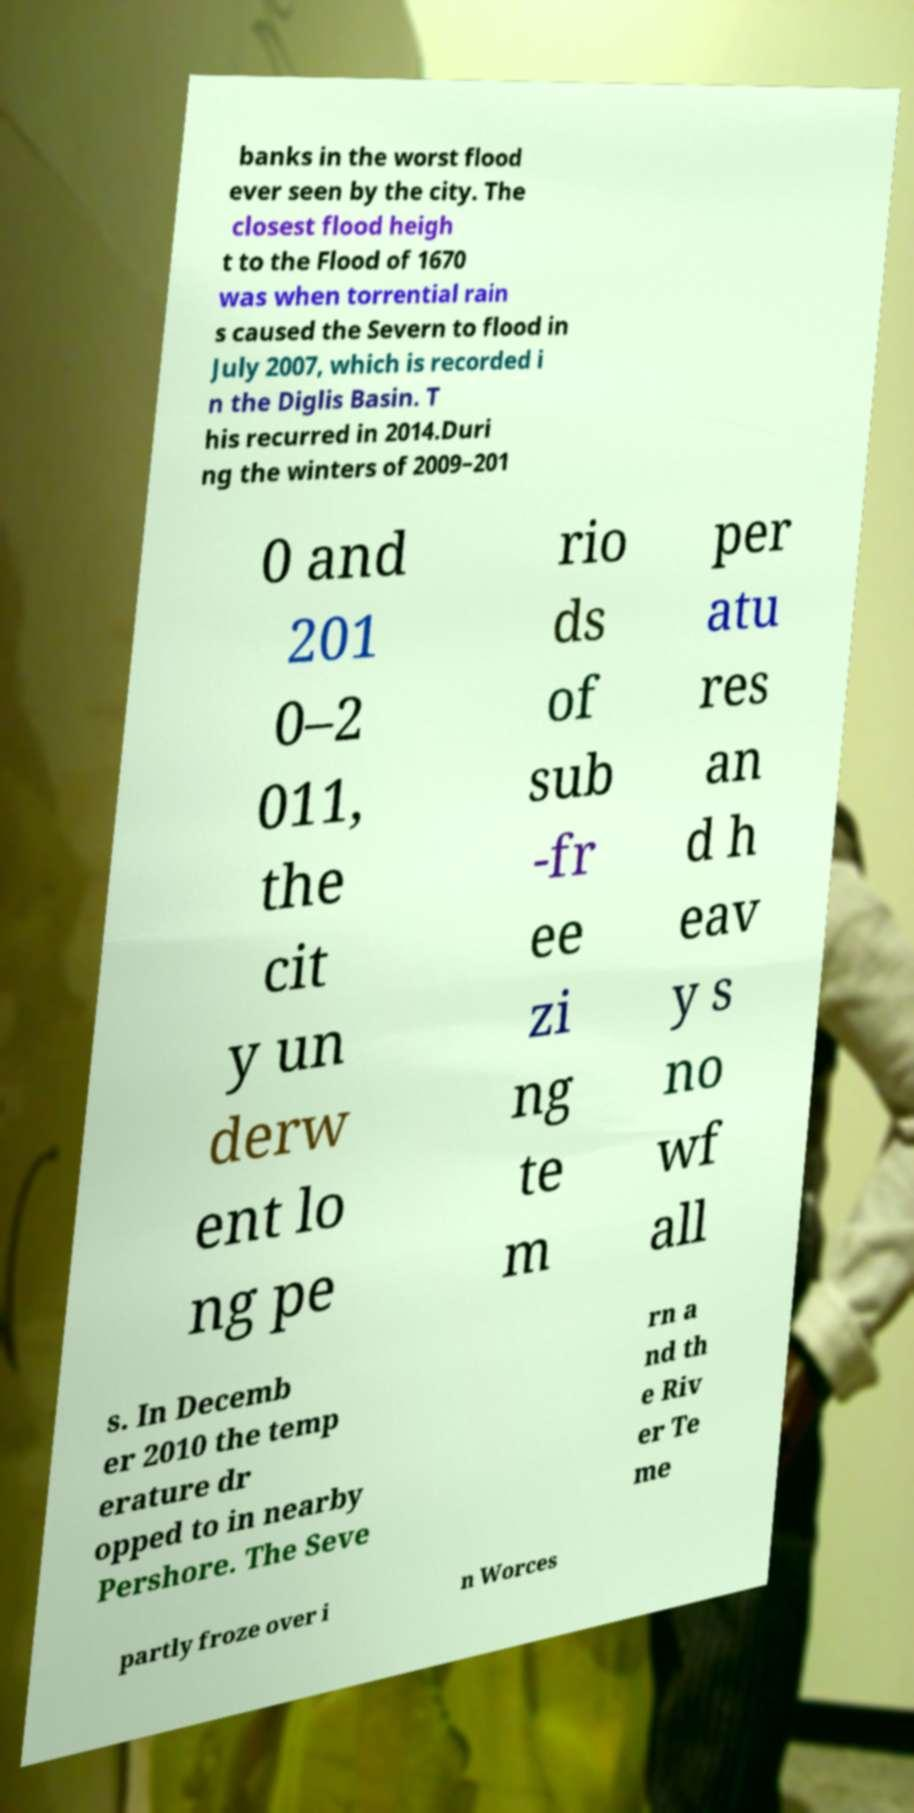Can you read and provide the text displayed in the image?This photo seems to have some interesting text. Can you extract and type it out for me? banks in the worst flood ever seen by the city. The closest flood heigh t to the Flood of 1670 was when torrential rain s caused the Severn to flood in July 2007, which is recorded i n the Diglis Basin. T his recurred in 2014.Duri ng the winters of 2009–201 0 and 201 0–2 011, the cit y un derw ent lo ng pe rio ds of sub -fr ee zi ng te m per atu res an d h eav y s no wf all s. In Decemb er 2010 the temp erature dr opped to in nearby Pershore. The Seve rn a nd th e Riv er Te me partly froze over i n Worces 